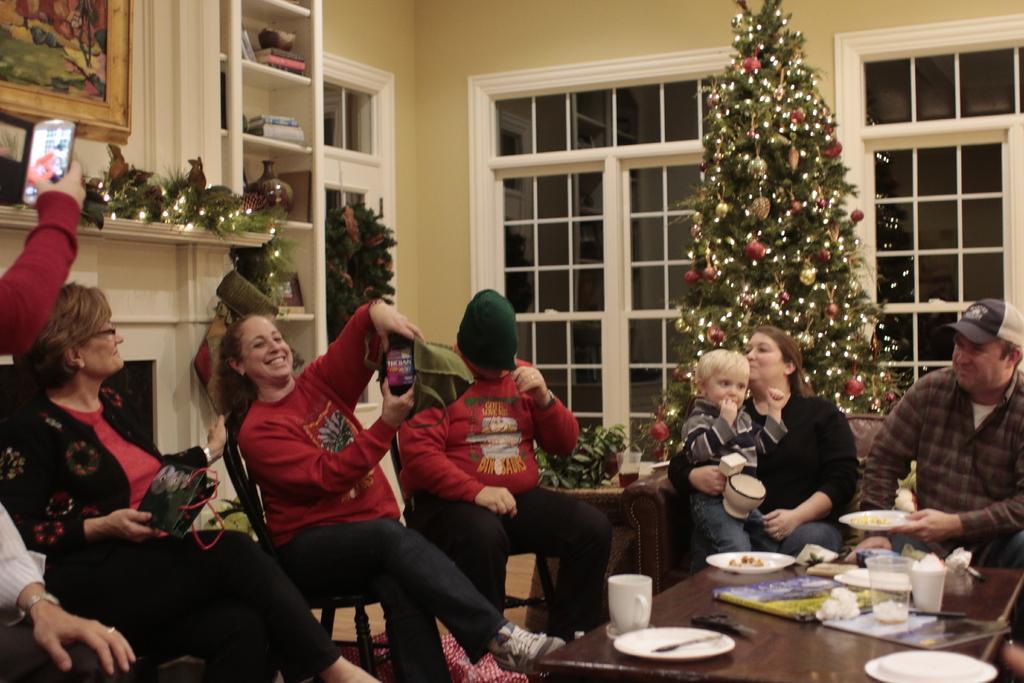Describe this image in one or two sentences. In this image we can see few people are sitting on the chairs. We can see cups, plates, books and tissues on the table. In the background there are photo frames on the wall, shelves, Christmas tree and glass windows. 